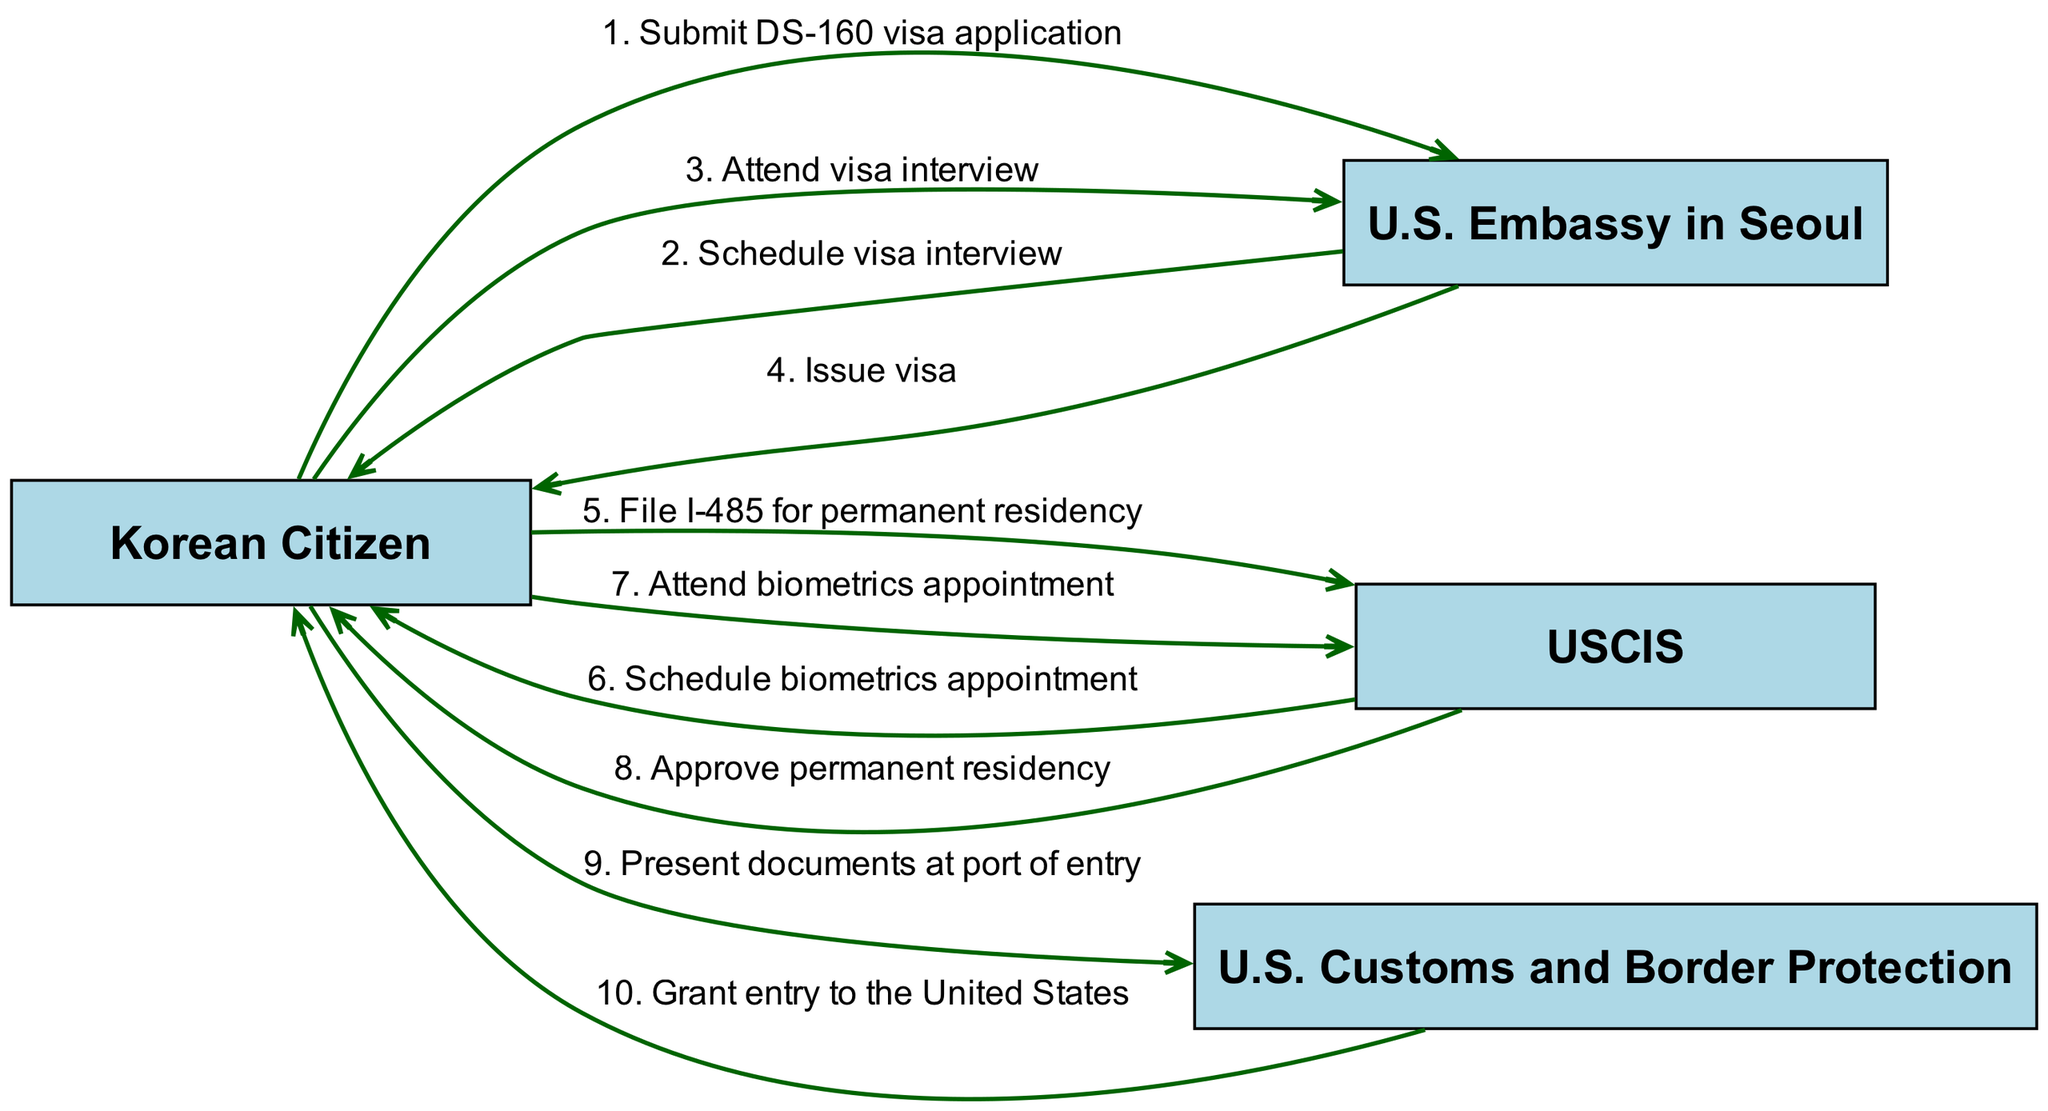What is the first action taken by the Korean Citizen? The diagram shows that the first action taken by the Korean Citizen is to submit the DS-160 visa application to the U.S. Embassy in Seoul, as it is the first edge in the sequence.
Answer: Submit DS-160 visa application How many nodes are present in the diagram? By counting the actors and omitting duplicates, the diagram has four distinct nodes: Korean Citizen, U.S. Embassy in Seoul, USCIS, and U.S. Customs and Border Protection.
Answer: Four What is the action taken by the U.S. Embassy in Seoul after the visa interview? The diagram indicates that after the visa interview, the U.S. Embassy in Seoul issues the visa to the Korean Citizen, which is the action outlined in the sequence.
Answer: Issue visa What are the last two actions in the sequence? By looking at the sequence, the last two actions are "Present documents at port of entry" taken by the Korean Citizen, and then "Grant entry to the United States" taken by the U.S. Customs and Border Protection.
Answer: Present documents at port of entry, Grant entry to the United States Which organization schedules the biometrics appointment? The diagram clearly shows that USCIS is responsible for scheduling the biometrics appointment as per the sequence following the filing of the I-485 for permanent residency.
Answer: USCIS How does the Korean Citizen eventually enter the United States? Following the sequence in the diagram, the Korean Citizen enters the United States by presenting their documents at the port of entry, after which U.S. Customs and Border Protection grants entry.
Answer: Presenting documents at port of entry What is the relationship between the Korean Citizen and the U.S. Embassy in Seoul after submitting the DS-160 application? After submitting the DS-160 visa application, the U.S. Embassy in Seoul schedules a visa interview with the Korean Citizen, showcasing a direct communication or action flow from the embassy to the citizen.
Answer: Schedule visa interview What is the purpose of filing the I-485 form? According to the sequence in the diagram, the purpose of filing the I-485 form is for the Korean Citizen to apply for permanent residency in the United States, which is indicated as the action taken after the visa issuance.
Answer: Apply for permanent residency 